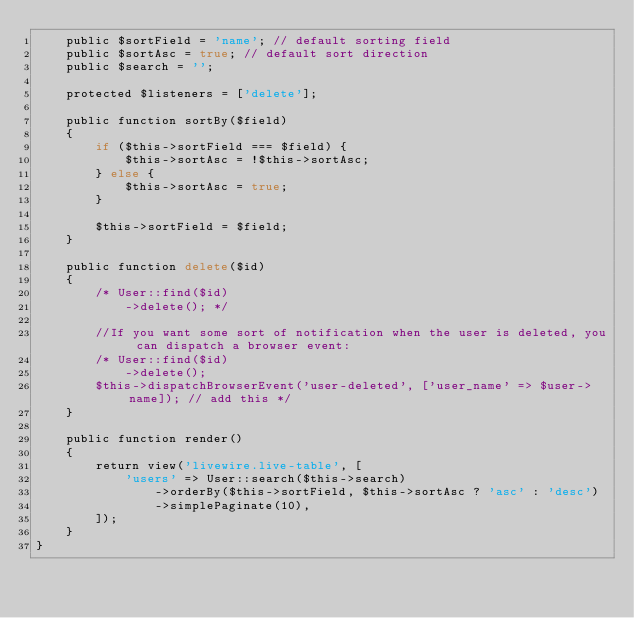Convert code to text. <code><loc_0><loc_0><loc_500><loc_500><_PHP_>    public $sortField = 'name'; // default sorting field
    public $sortAsc = true; // default sort direction
    public $search = '';

    protected $listeners = ['delete'];

    public function sortBy($field)
    {
        if ($this->sortField === $field) {
            $this->sortAsc = !$this->sortAsc;
        } else {
            $this->sortAsc = true;
        }

        $this->sortField = $field;
    }

    public function delete($id)
    {
        /* User::find($id)
            ->delete(); */

        //If you want some sort of notification when the user is deleted, you can dispatch a browser event:
        /* User::find($id)
            ->delete();
        $this->dispatchBrowserEvent('user-deleted', ['user_name' => $user->name]); // add this */
    }

    public function render()
    {
        return view('livewire.live-table', [
            'users' => User::search($this->search)
                ->orderBy($this->sortField, $this->sortAsc ? 'asc' : 'desc')
                ->simplePaginate(10),
        ]);
    }
}
</code> 